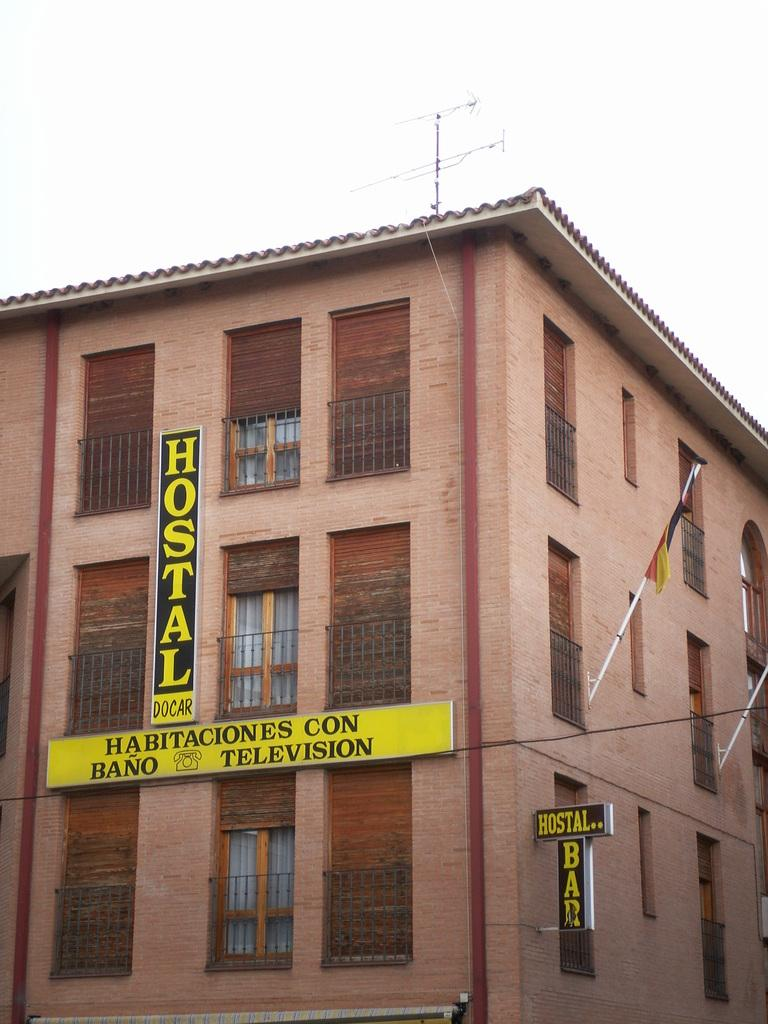What type of structure is visible in the image? There is a building in the image. What is written on the building? The building has "hostal docar" written on it. Is there any other object visible in the image? Yes, there is a flag attached to a pole in the right corner of the image. Is there a honeycomb visible in the image? No, there is no honeycomb present in the image. What type of plantation can be seen in the background of the image? There is no plantation visible in the image; it only features a building and a flag. 